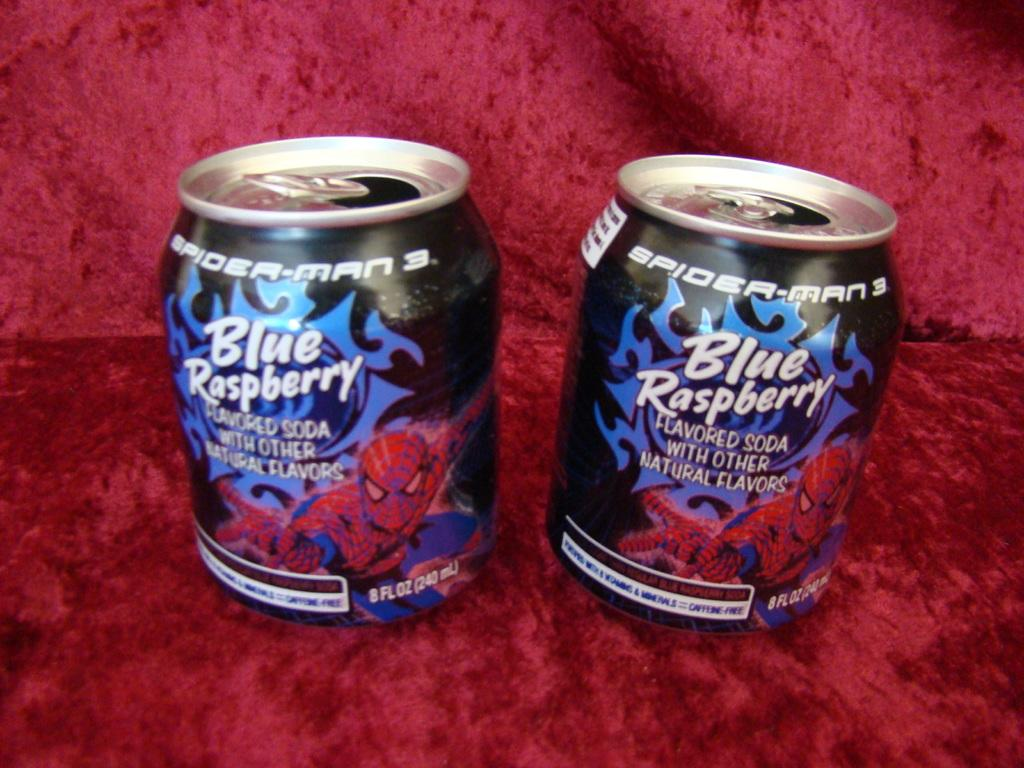Provide a one-sentence caption for the provided image. Two small cans of blue raspberry soda sit on a red velvet cloth. 